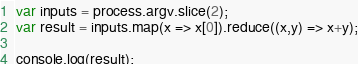Convert code to text. <code><loc_0><loc_0><loc_500><loc_500><_JavaScript_>var inputs = process.argv.slice(2);
var result = inputs.map(x => x[0]).reduce((x,y) => x+y);

console.log(result);</code> 